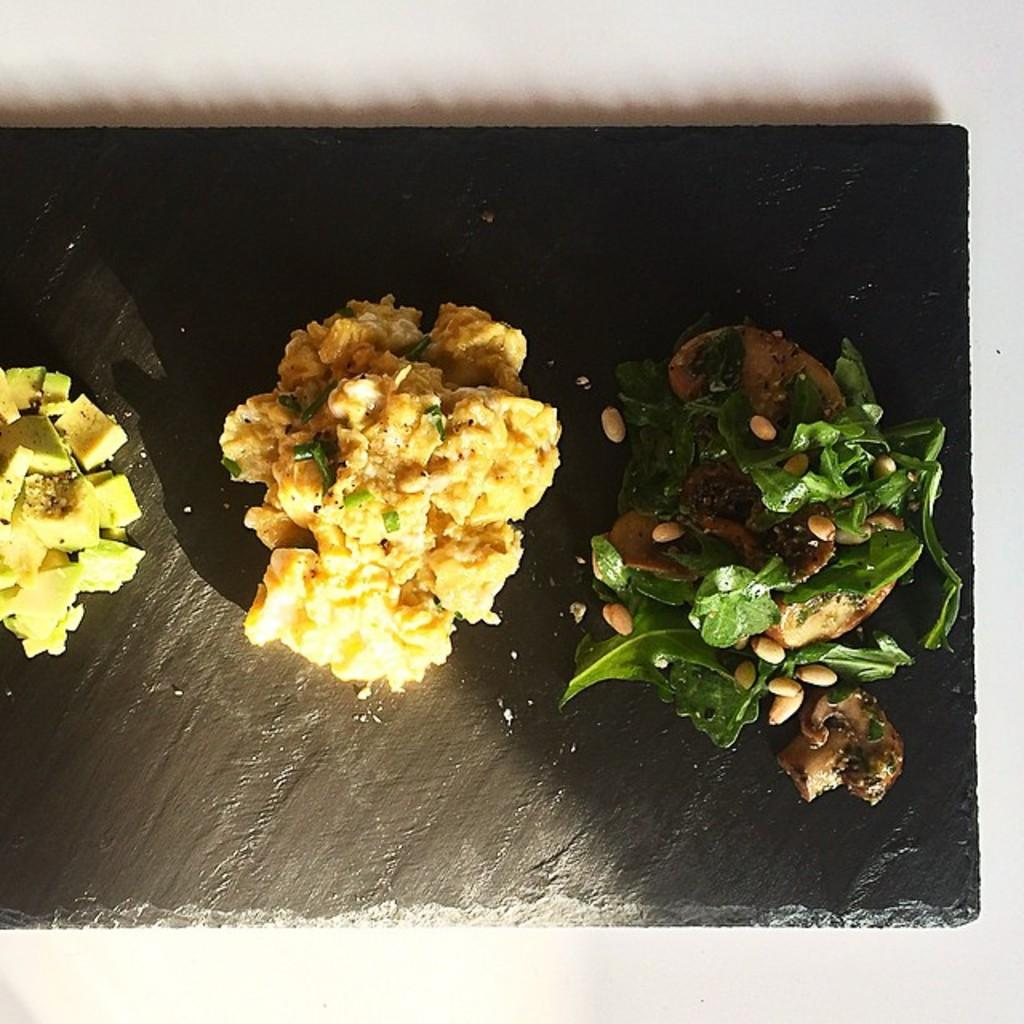What is the main subject of the image? The main subject of the image is food. Where is the food located in the image? The food is present on a platform. What type of engine is powering the food in the image? There is no engine present in the image, and the food is not being powered by any engine. What type of bait is used to attract the fowl in the image? There is no bait or fowl present in the image; it only features food on a platform. 